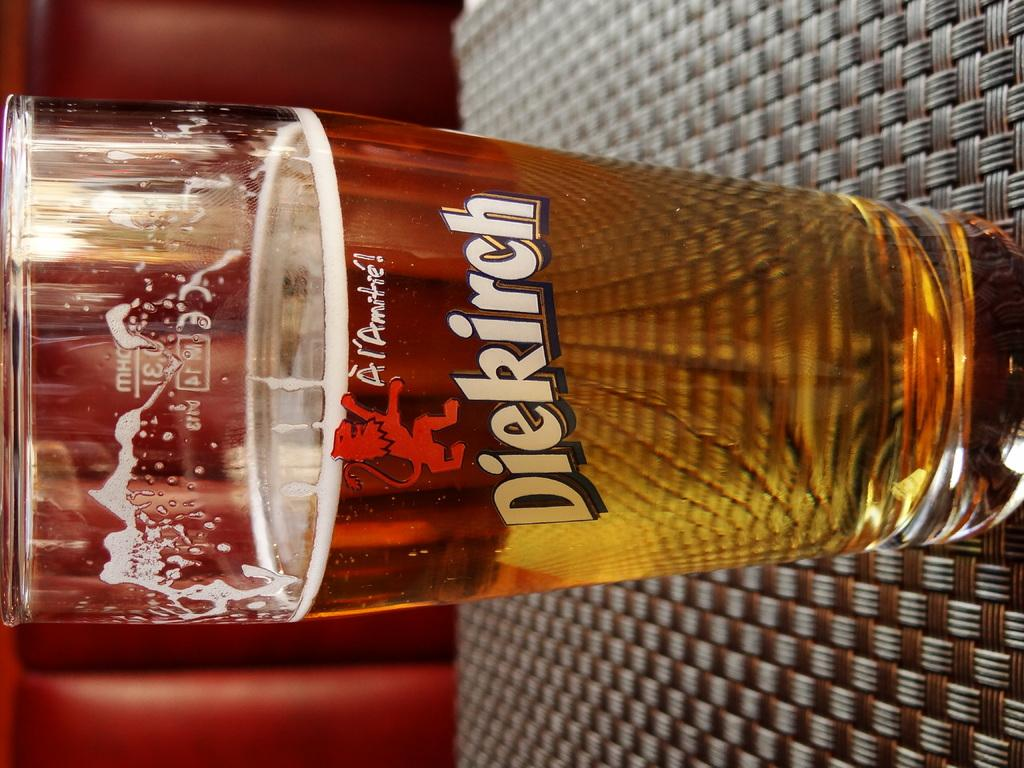<image>
Summarize the visual content of the image. A glass of beer with the word Diekirch written on it 